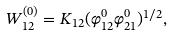<formula> <loc_0><loc_0><loc_500><loc_500>W _ { 1 2 } ^ { ( 0 ) } = K _ { 1 2 } ( \varphi _ { 1 2 } ^ { 0 } \varphi _ { 2 1 } ^ { 0 } ) ^ { 1 / 2 } ,</formula> 